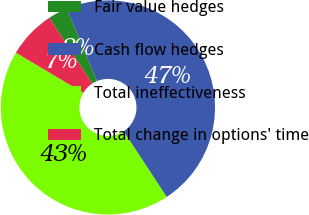Convert chart. <chart><loc_0><loc_0><loc_500><loc_500><pie_chart><fcel>Fair value hedges<fcel>Cash flow hedges<fcel>Total ineffectiveness<fcel>Total change in options' time<nl><fcel>2.95%<fcel>47.05%<fcel>42.77%<fcel>7.23%<nl></chart> 